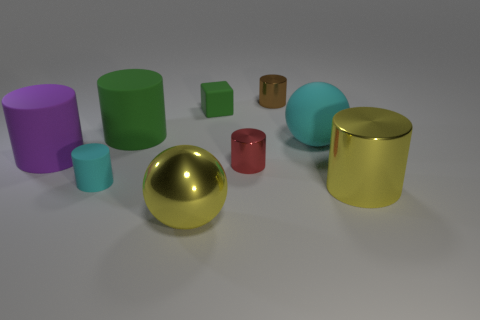Subtract all brown cylinders. How many cylinders are left? 5 Subtract all small metal cylinders. How many cylinders are left? 4 Subtract all cyan cylinders. Subtract all gray blocks. How many cylinders are left? 5 Add 1 green metal spheres. How many objects exist? 10 Subtract all balls. How many objects are left? 7 Subtract all big green cylinders. Subtract all small objects. How many objects are left? 4 Add 8 matte balls. How many matte balls are left? 9 Add 4 tiny red spheres. How many tiny red spheres exist? 4 Subtract 1 cyan balls. How many objects are left? 8 